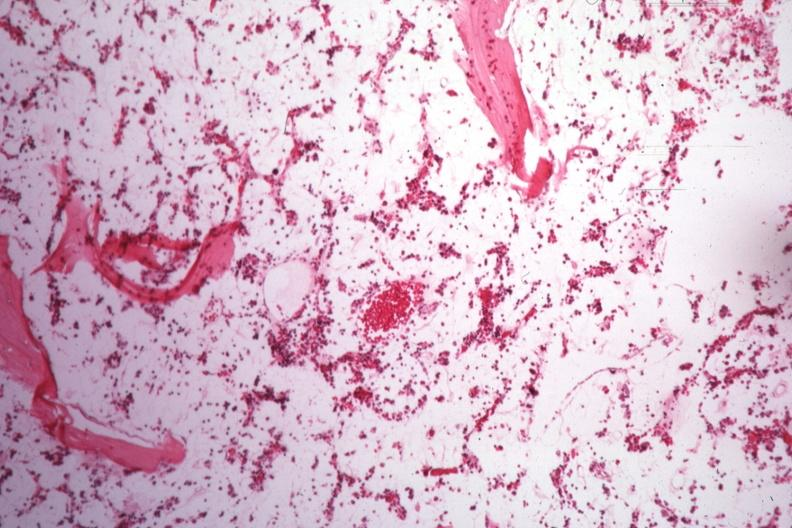s malignant histiocytosis present?
Answer the question using a single word or phrase. No 